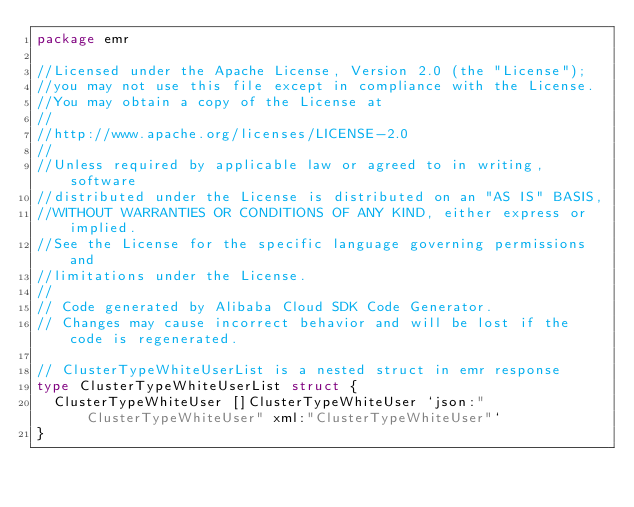Convert code to text. <code><loc_0><loc_0><loc_500><loc_500><_Go_>package emr

//Licensed under the Apache License, Version 2.0 (the "License");
//you may not use this file except in compliance with the License.
//You may obtain a copy of the License at
//
//http://www.apache.org/licenses/LICENSE-2.0
//
//Unless required by applicable law or agreed to in writing, software
//distributed under the License is distributed on an "AS IS" BASIS,
//WITHOUT WARRANTIES OR CONDITIONS OF ANY KIND, either express or implied.
//See the License for the specific language governing permissions and
//limitations under the License.
//
// Code generated by Alibaba Cloud SDK Code Generator.
// Changes may cause incorrect behavior and will be lost if the code is regenerated.

// ClusterTypeWhiteUserList is a nested struct in emr response
type ClusterTypeWhiteUserList struct {
	ClusterTypeWhiteUser []ClusterTypeWhiteUser `json:"ClusterTypeWhiteUser" xml:"ClusterTypeWhiteUser"`
}
</code> 